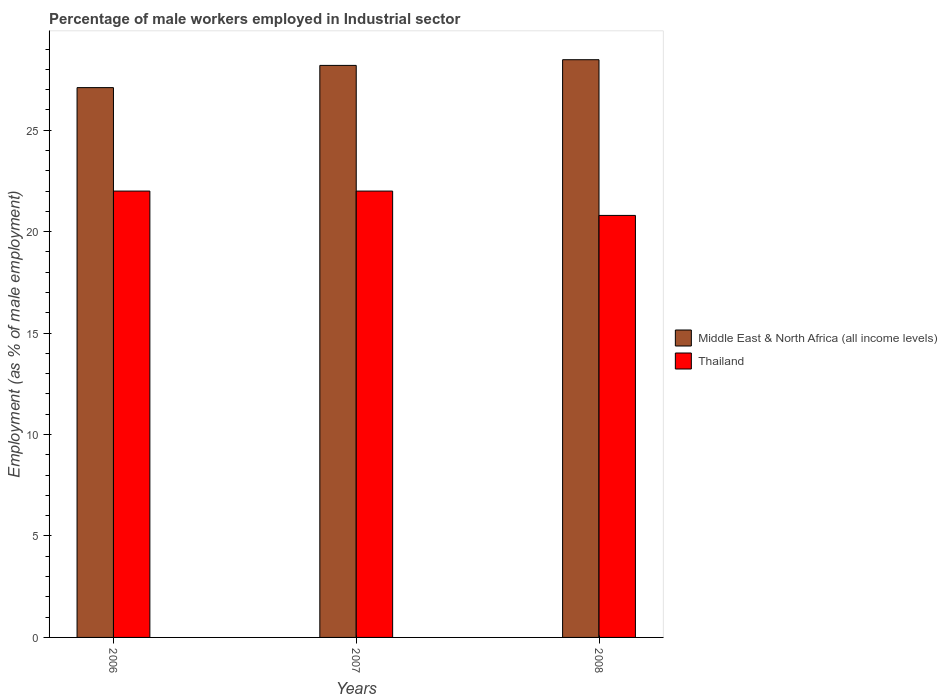How many groups of bars are there?
Provide a succinct answer. 3. Are the number of bars per tick equal to the number of legend labels?
Make the answer very short. Yes. Are the number of bars on each tick of the X-axis equal?
Make the answer very short. Yes. How many bars are there on the 1st tick from the left?
Your answer should be compact. 2. What is the label of the 3rd group of bars from the left?
Keep it short and to the point. 2008. What is the percentage of male workers employed in Industrial sector in Middle East & North Africa (all income levels) in 2006?
Make the answer very short. 27.1. Across all years, what is the maximum percentage of male workers employed in Industrial sector in Middle East & North Africa (all income levels)?
Ensure brevity in your answer.  28.47. Across all years, what is the minimum percentage of male workers employed in Industrial sector in Middle East & North Africa (all income levels)?
Make the answer very short. 27.1. What is the total percentage of male workers employed in Industrial sector in Thailand in the graph?
Give a very brief answer. 64.8. What is the difference between the percentage of male workers employed in Industrial sector in Thailand in 2006 and that in 2008?
Your answer should be compact. 1.2. What is the difference between the percentage of male workers employed in Industrial sector in Middle East & North Africa (all income levels) in 2007 and the percentage of male workers employed in Industrial sector in Thailand in 2006?
Keep it short and to the point. 6.19. What is the average percentage of male workers employed in Industrial sector in Middle East & North Africa (all income levels) per year?
Your answer should be compact. 27.92. In the year 2007, what is the difference between the percentage of male workers employed in Industrial sector in Thailand and percentage of male workers employed in Industrial sector in Middle East & North Africa (all income levels)?
Your answer should be compact. -6.19. In how many years, is the percentage of male workers employed in Industrial sector in Thailand greater than 4 %?
Keep it short and to the point. 3. What is the ratio of the percentage of male workers employed in Industrial sector in Thailand in 2006 to that in 2008?
Offer a terse response. 1.06. Is the percentage of male workers employed in Industrial sector in Thailand in 2006 less than that in 2008?
Offer a very short reply. No. Is the difference between the percentage of male workers employed in Industrial sector in Thailand in 2006 and 2007 greater than the difference between the percentage of male workers employed in Industrial sector in Middle East & North Africa (all income levels) in 2006 and 2007?
Offer a very short reply. Yes. What is the difference between the highest and the second highest percentage of male workers employed in Industrial sector in Thailand?
Keep it short and to the point. 0. What is the difference between the highest and the lowest percentage of male workers employed in Industrial sector in Middle East & North Africa (all income levels)?
Ensure brevity in your answer.  1.38. In how many years, is the percentage of male workers employed in Industrial sector in Middle East & North Africa (all income levels) greater than the average percentage of male workers employed in Industrial sector in Middle East & North Africa (all income levels) taken over all years?
Offer a very short reply. 2. What does the 1st bar from the left in 2008 represents?
Keep it short and to the point. Middle East & North Africa (all income levels). What does the 1st bar from the right in 2008 represents?
Your answer should be compact. Thailand. Are all the bars in the graph horizontal?
Provide a succinct answer. No. What is the difference between two consecutive major ticks on the Y-axis?
Make the answer very short. 5. Are the values on the major ticks of Y-axis written in scientific E-notation?
Make the answer very short. No. Does the graph contain any zero values?
Provide a short and direct response. No. Does the graph contain grids?
Offer a very short reply. No. How many legend labels are there?
Keep it short and to the point. 2. What is the title of the graph?
Provide a succinct answer. Percentage of male workers employed in Industrial sector. Does "Armenia" appear as one of the legend labels in the graph?
Provide a succinct answer. No. What is the label or title of the Y-axis?
Ensure brevity in your answer.  Employment (as % of male employment). What is the Employment (as % of male employment) in Middle East & North Africa (all income levels) in 2006?
Ensure brevity in your answer.  27.1. What is the Employment (as % of male employment) of Thailand in 2006?
Ensure brevity in your answer.  22. What is the Employment (as % of male employment) of Middle East & North Africa (all income levels) in 2007?
Keep it short and to the point. 28.19. What is the Employment (as % of male employment) of Thailand in 2007?
Offer a terse response. 22. What is the Employment (as % of male employment) of Middle East & North Africa (all income levels) in 2008?
Your answer should be compact. 28.47. What is the Employment (as % of male employment) of Thailand in 2008?
Provide a succinct answer. 20.8. Across all years, what is the maximum Employment (as % of male employment) in Middle East & North Africa (all income levels)?
Offer a very short reply. 28.47. Across all years, what is the maximum Employment (as % of male employment) in Thailand?
Your response must be concise. 22. Across all years, what is the minimum Employment (as % of male employment) of Middle East & North Africa (all income levels)?
Give a very brief answer. 27.1. Across all years, what is the minimum Employment (as % of male employment) of Thailand?
Provide a short and direct response. 20.8. What is the total Employment (as % of male employment) of Middle East & North Africa (all income levels) in the graph?
Offer a very short reply. 83.77. What is the total Employment (as % of male employment) in Thailand in the graph?
Provide a succinct answer. 64.8. What is the difference between the Employment (as % of male employment) of Middle East & North Africa (all income levels) in 2006 and that in 2007?
Make the answer very short. -1.1. What is the difference between the Employment (as % of male employment) of Middle East & North Africa (all income levels) in 2006 and that in 2008?
Make the answer very short. -1.38. What is the difference between the Employment (as % of male employment) in Thailand in 2006 and that in 2008?
Offer a terse response. 1.2. What is the difference between the Employment (as % of male employment) of Middle East & North Africa (all income levels) in 2007 and that in 2008?
Offer a very short reply. -0.28. What is the difference between the Employment (as % of male employment) in Middle East & North Africa (all income levels) in 2006 and the Employment (as % of male employment) in Thailand in 2007?
Ensure brevity in your answer.  5.1. What is the difference between the Employment (as % of male employment) of Middle East & North Africa (all income levels) in 2006 and the Employment (as % of male employment) of Thailand in 2008?
Provide a succinct answer. 6.3. What is the difference between the Employment (as % of male employment) of Middle East & North Africa (all income levels) in 2007 and the Employment (as % of male employment) of Thailand in 2008?
Ensure brevity in your answer.  7.39. What is the average Employment (as % of male employment) in Middle East & North Africa (all income levels) per year?
Give a very brief answer. 27.92. What is the average Employment (as % of male employment) in Thailand per year?
Provide a short and direct response. 21.6. In the year 2006, what is the difference between the Employment (as % of male employment) of Middle East & North Africa (all income levels) and Employment (as % of male employment) of Thailand?
Ensure brevity in your answer.  5.1. In the year 2007, what is the difference between the Employment (as % of male employment) in Middle East & North Africa (all income levels) and Employment (as % of male employment) in Thailand?
Your response must be concise. 6.19. In the year 2008, what is the difference between the Employment (as % of male employment) of Middle East & North Africa (all income levels) and Employment (as % of male employment) of Thailand?
Give a very brief answer. 7.67. What is the ratio of the Employment (as % of male employment) of Middle East & North Africa (all income levels) in 2006 to that in 2007?
Your response must be concise. 0.96. What is the ratio of the Employment (as % of male employment) in Thailand in 2006 to that in 2007?
Your answer should be compact. 1. What is the ratio of the Employment (as % of male employment) of Middle East & North Africa (all income levels) in 2006 to that in 2008?
Your response must be concise. 0.95. What is the ratio of the Employment (as % of male employment) of Thailand in 2006 to that in 2008?
Ensure brevity in your answer.  1.06. What is the ratio of the Employment (as % of male employment) of Middle East & North Africa (all income levels) in 2007 to that in 2008?
Provide a short and direct response. 0.99. What is the ratio of the Employment (as % of male employment) of Thailand in 2007 to that in 2008?
Make the answer very short. 1.06. What is the difference between the highest and the second highest Employment (as % of male employment) in Middle East & North Africa (all income levels)?
Provide a succinct answer. 0.28. What is the difference between the highest and the second highest Employment (as % of male employment) of Thailand?
Your response must be concise. 0. What is the difference between the highest and the lowest Employment (as % of male employment) in Middle East & North Africa (all income levels)?
Offer a terse response. 1.38. What is the difference between the highest and the lowest Employment (as % of male employment) of Thailand?
Make the answer very short. 1.2. 